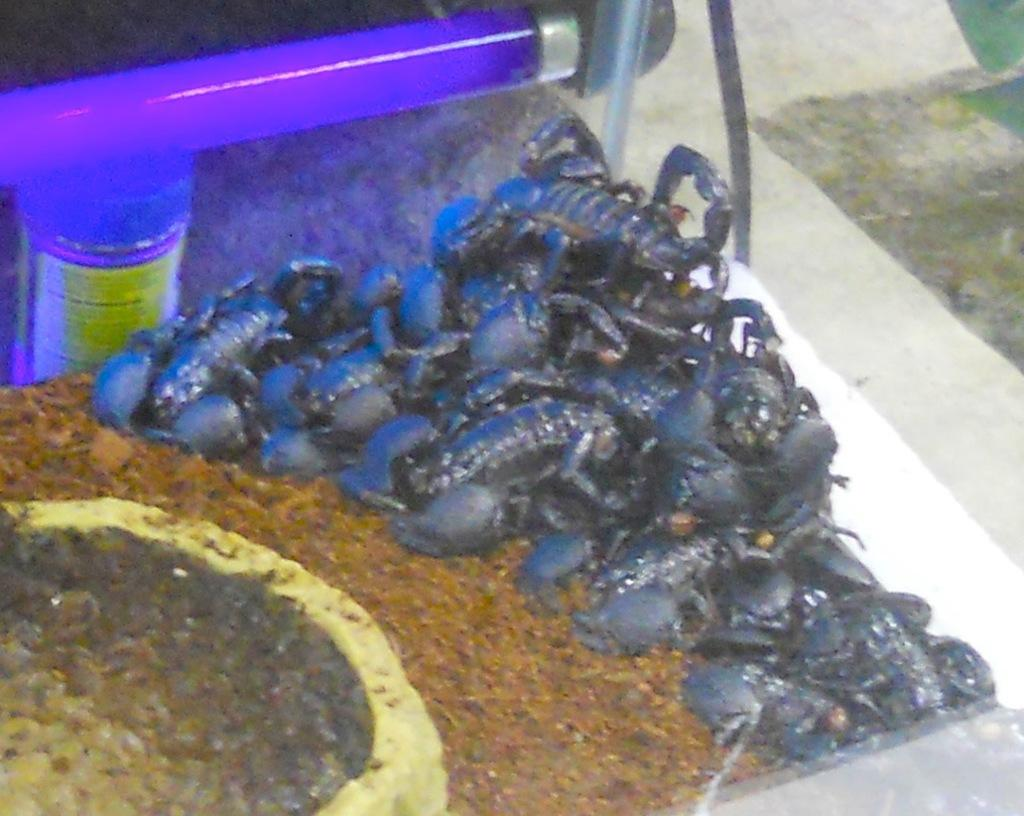What creatures are present in the image? There are scorpions in the image. What type of terrain is depicted in the image? There is mud in the image. Are there any other objects or features in the image besides the scorpions and mud? Yes, there are other objects in the image. Can you describe the background of the image? There is a glass object and light visible in the background of the image. What type of cabbage is being exchanged in the image? There is no cabbage or exchange of any kind present in the image. What class of students is attending the lecture in the image? There is no class or lecture depicted in the image. 